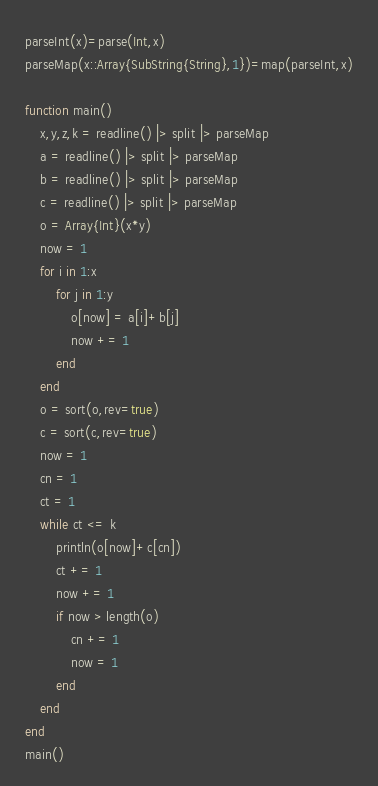Convert code to text. <code><loc_0><loc_0><loc_500><loc_500><_Julia_>parseInt(x)=parse(Int,x)
parseMap(x::Array{SubString{String},1})=map(parseInt,x)

function main()
	x,y,z,k = readline() |> split |> parseMap
	a = readline() |> split |> parseMap
	b = readline() |> split |> parseMap
	c = readline() |> split |> parseMap
	o = Array{Int}(x*y)
	now = 1
	for i in 1:x
		for j in 1:y
			o[now] = a[i]+b[j]
			now += 1
		end
	end
	o = sort(o,rev=true)
	c = sort(c,rev=true)
	now = 1
	cn = 1
	ct = 1
	while ct <= k
		println(o[now]+c[cn])
		ct += 1
		now += 1
		if now > length(o)
			cn += 1
			now = 1
		end
	end
end
main()
</code> 